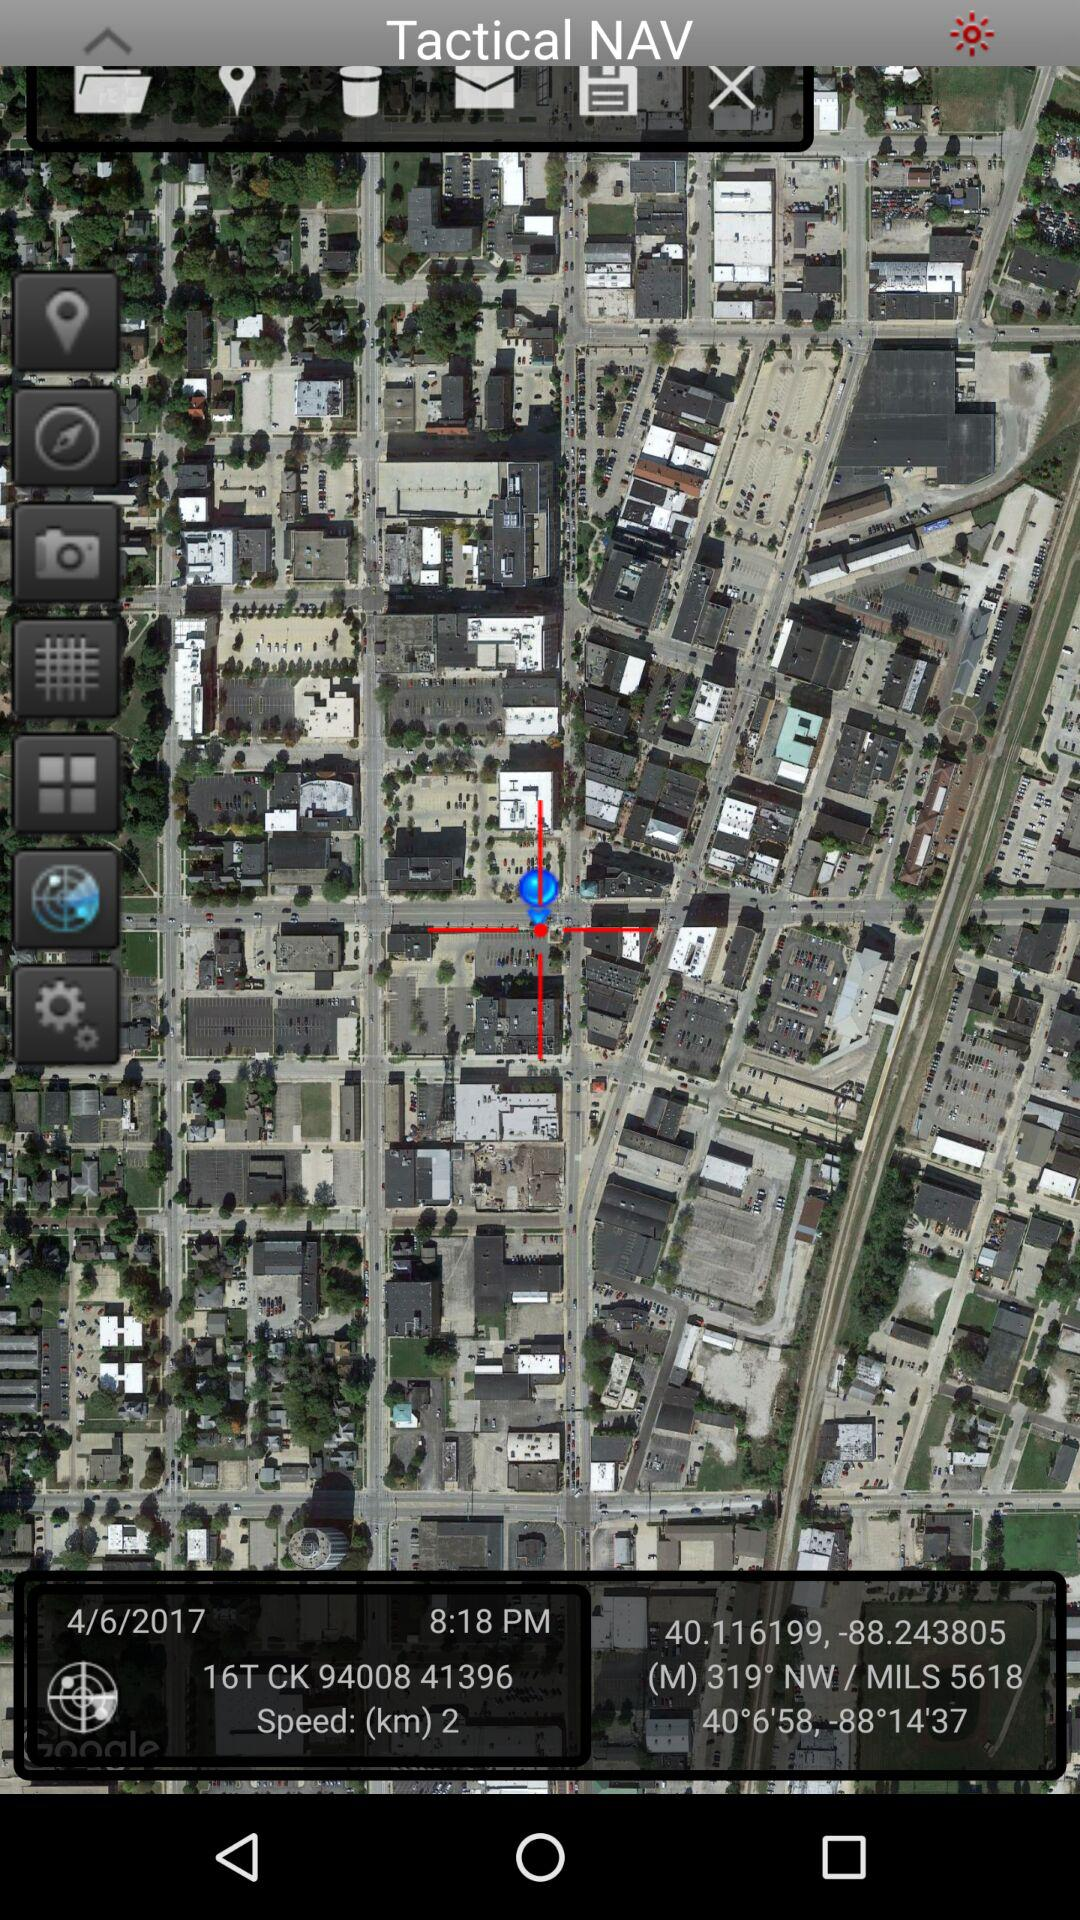What is the mentioned unit of speed? The mentioned unit of speed is km. 